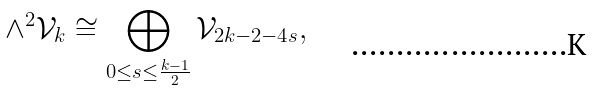<formula> <loc_0><loc_0><loc_500><loc_500>\wedge ^ { 2 } \mathcal { V } _ { k } \cong \bigoplus _ { 0 \leq s \leq \frac { k - 1 } { 2 } } \mathcal { V } _ { 2 k - 2 - 4 s } ,</formula> 